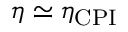Convert formula to latex. <formula><loc_0><loc_0><loc_500><loc_500>\eta \simeq \eta _ { C P I }</formula> 